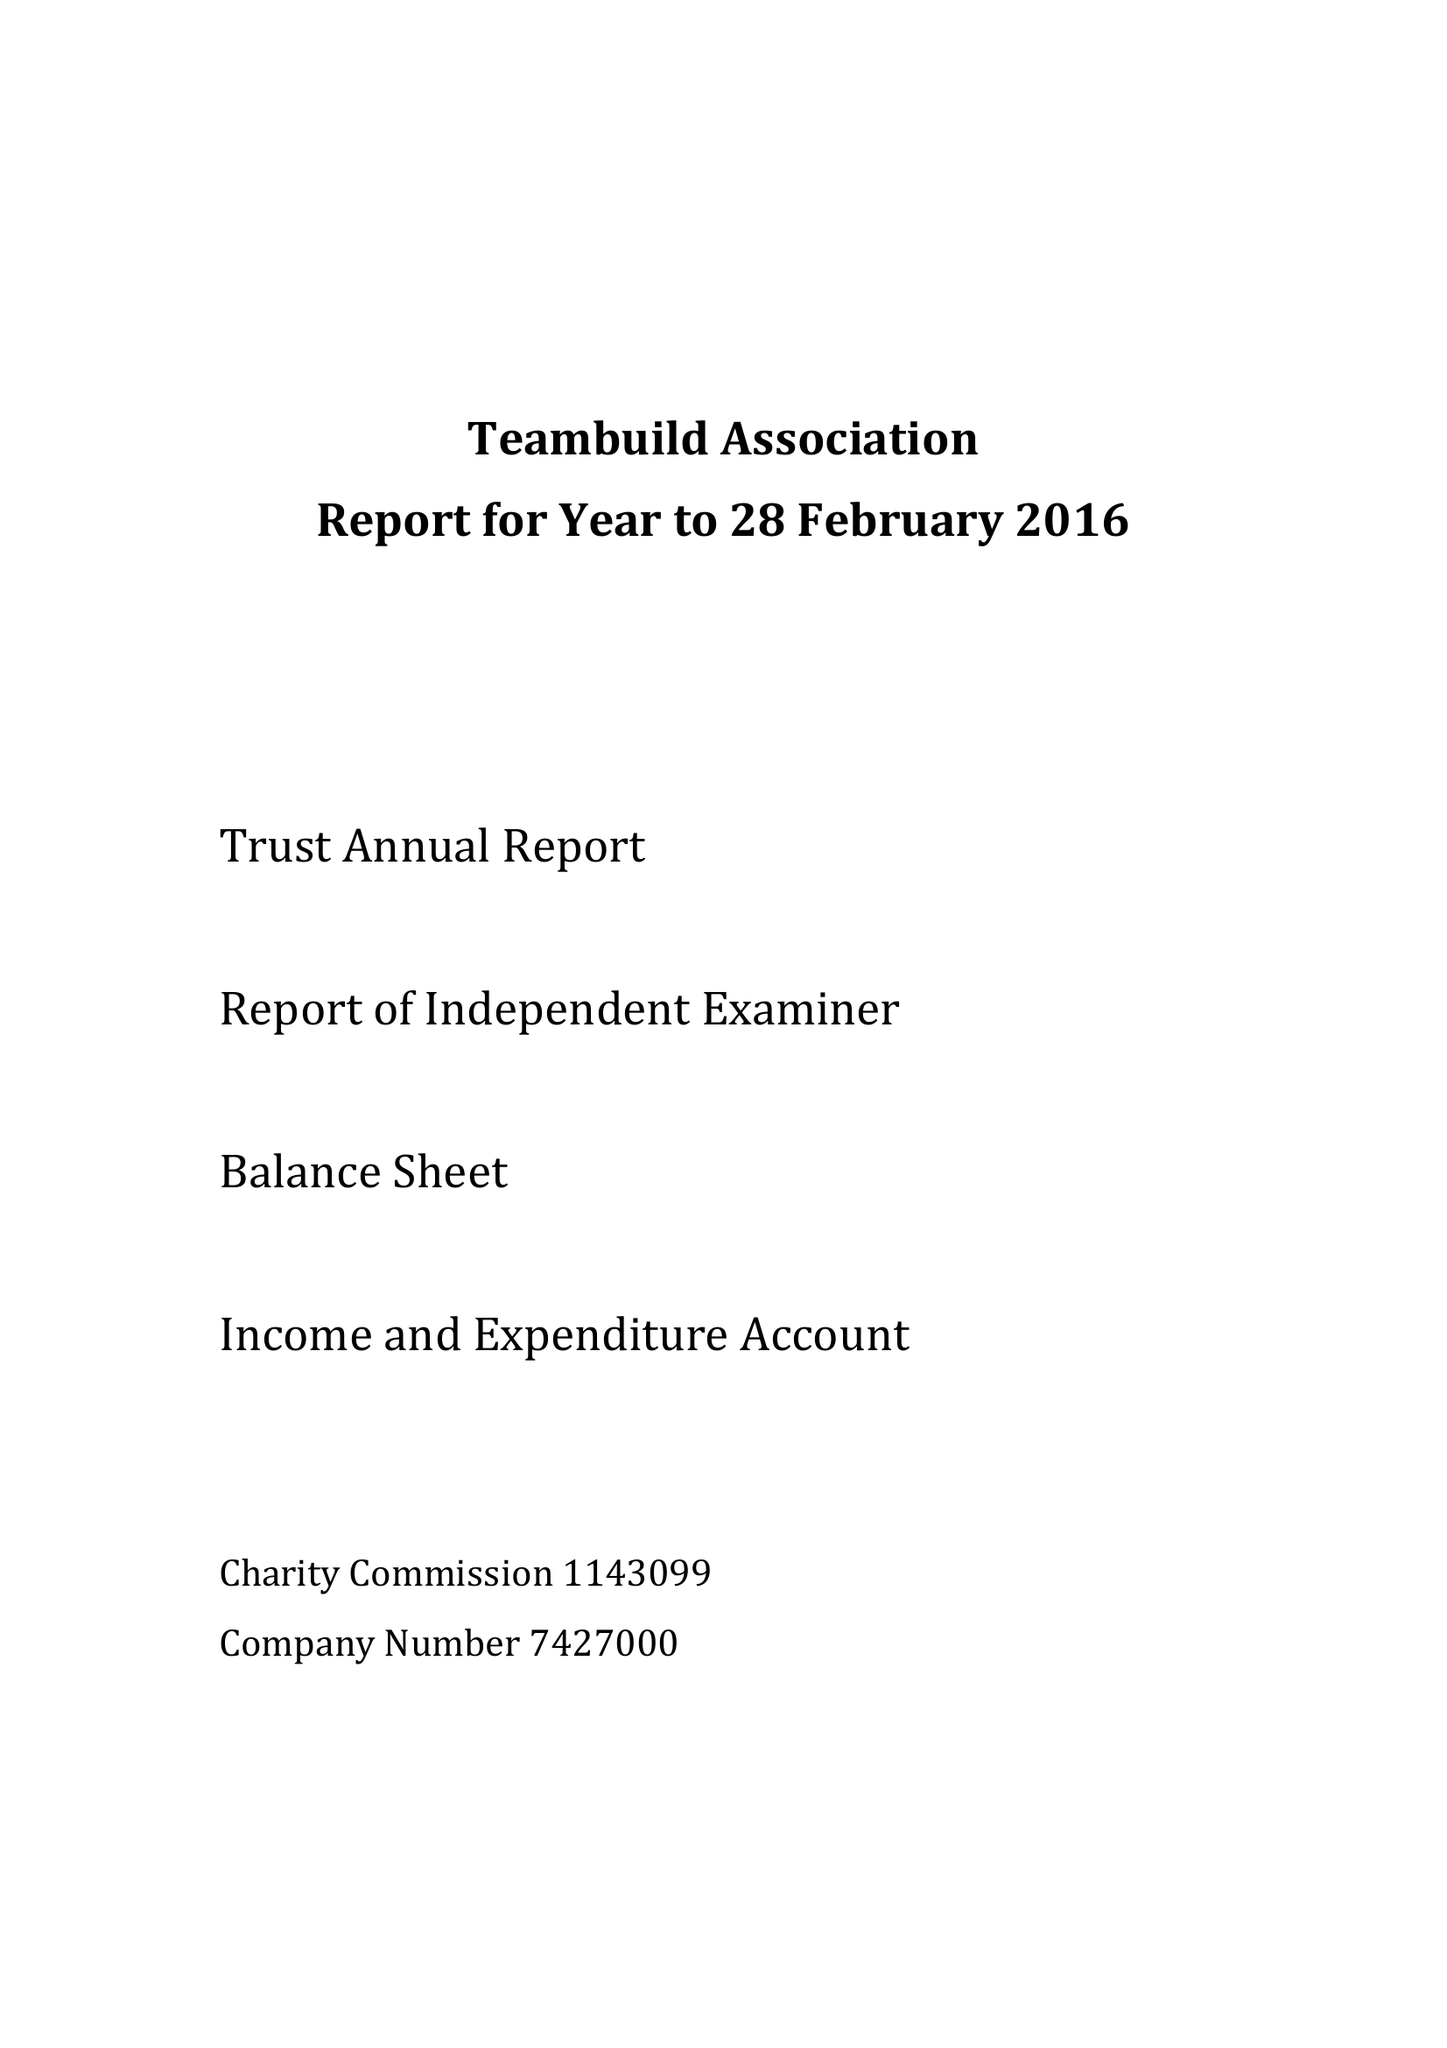What is the value for the charity_number?
Answer the question using a single word or phrase. 1143099 